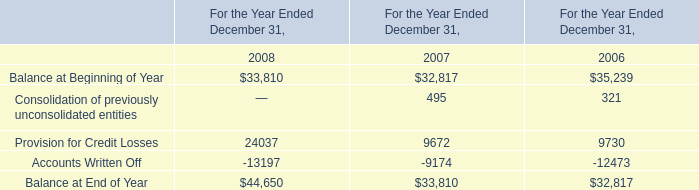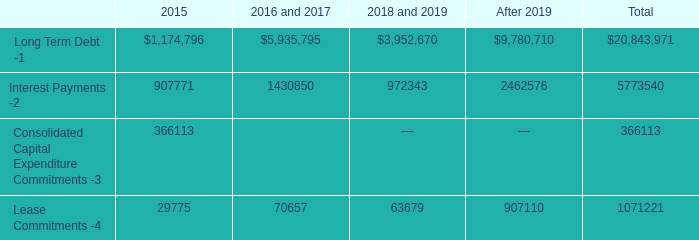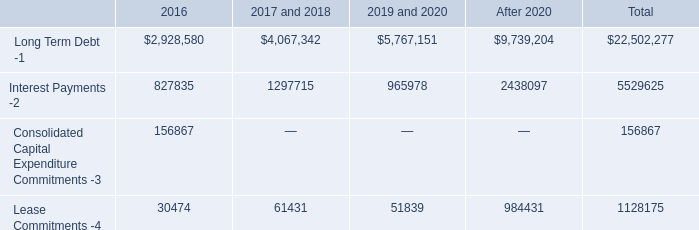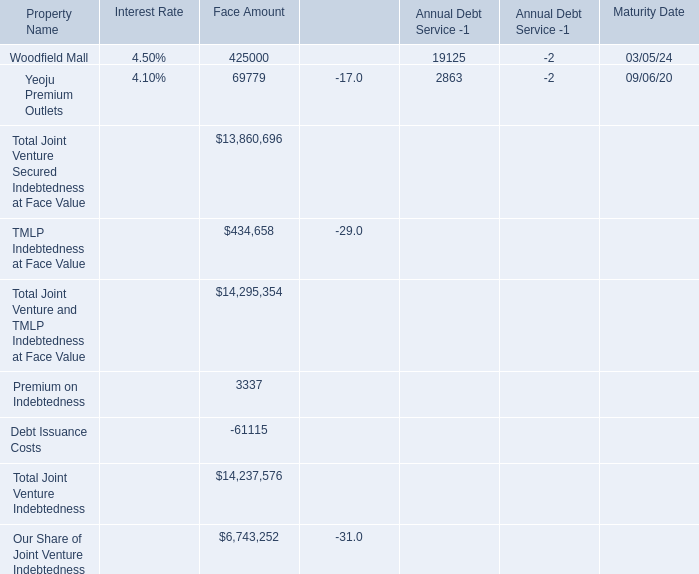What's the 50 % of the Face Amount for TMLP Indebtedness at Face Value? 
Computations: (0.5 * 434658)
Answer: 217329.0. 